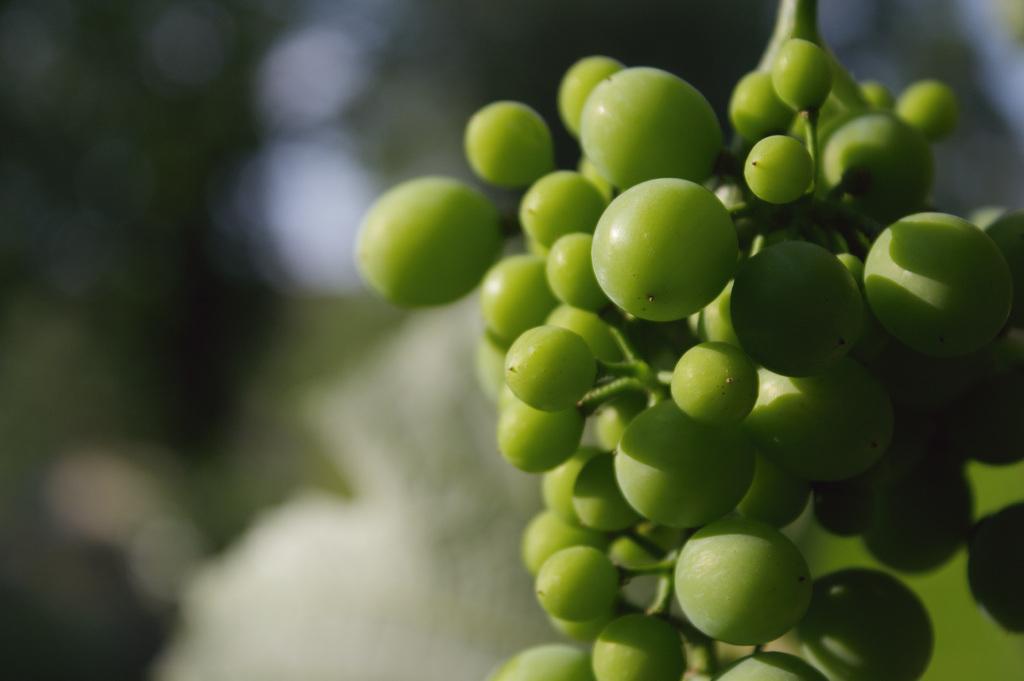How would you summarize this image in a sentence or two? In this image, we can see some green color fruits and there is a blur background. 